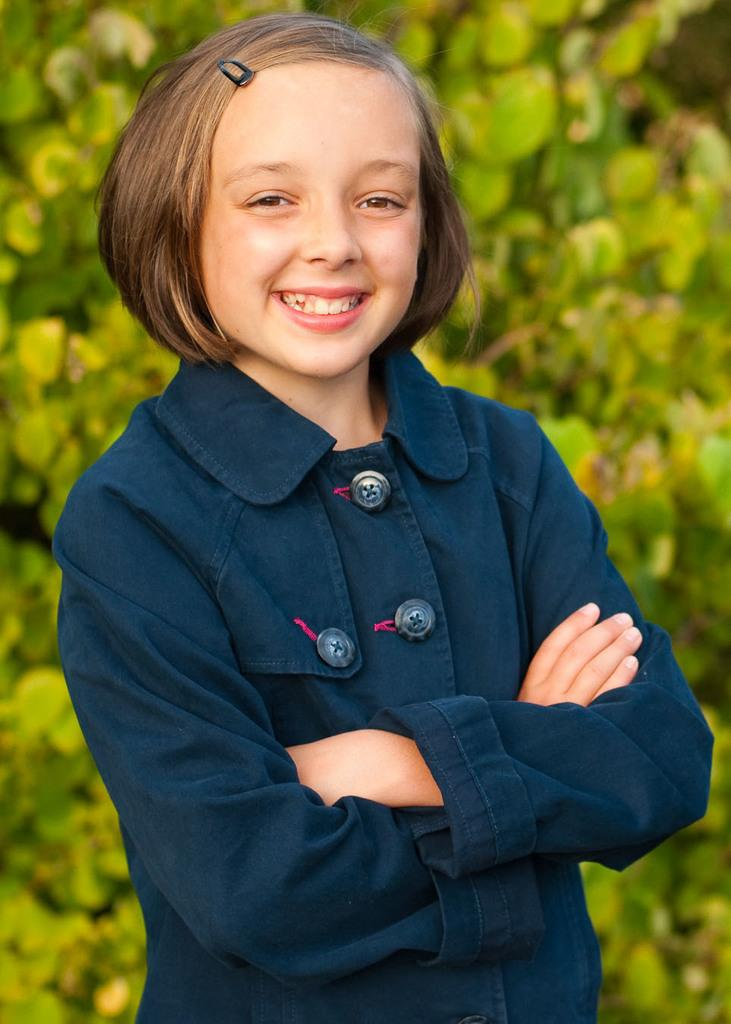Who is the main subject in the image? There is a girl in the image. What is the girl doing in the image? The girl is standing and smiling. What can be seen in the background of the image? There are trees in the background of the image. What type of rice is being used to create the stamp in the image? There is no rice or stamp present in the image. How does the girl show respect to the trees in the image? The image does not show the girl interacting with the trees or expressing respect towards them. 